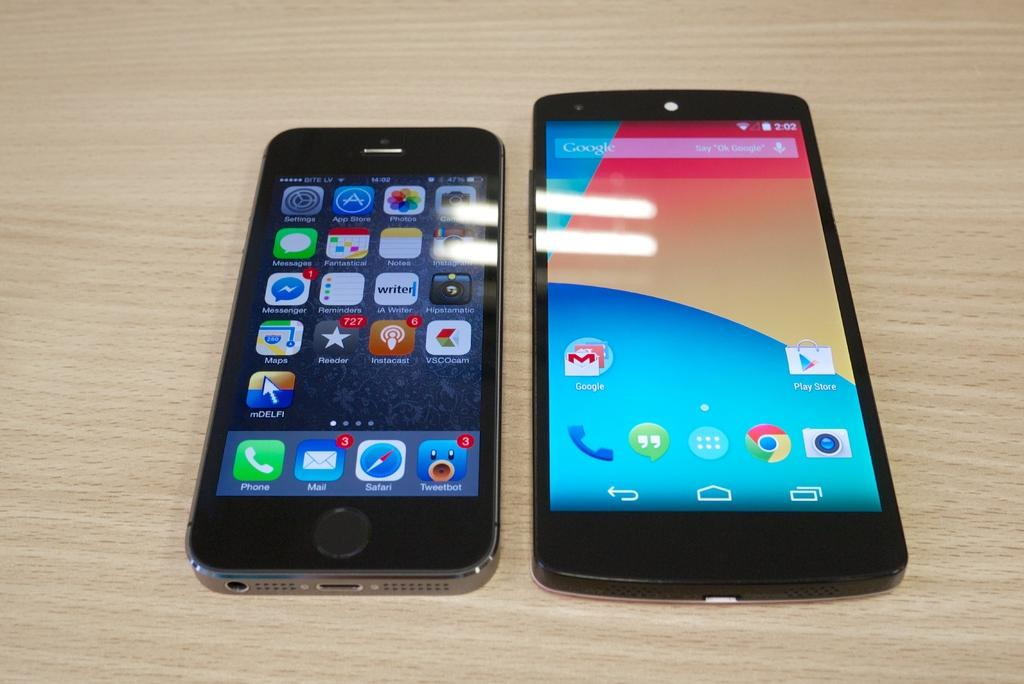<image>
Give a short and clear explanation of the subsequent image. An iPhone says the time is 14:02, and the phone next to it says the time is 2:02. 